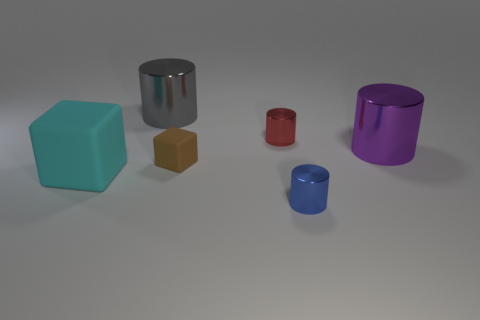Does the gray thing have the same size as the red metal object?
Your answer should be very brief. No. There is a thing that is left of the large metal thing to the left of the small brown rubber thing behind the large cyan rubber object; what is its material?
Your answer should be very brief. Rubber. Is the tiny cylinder that is in front of the big purple cylinder made of the same material as the tiny brown object?
Provide a short and direct response. No. What shape is the big object that is on the left side of the tiny red cylinder and in front of the gray thing?
Make the answer very short. Cube. What number of tiny things are cyan rubber things or shiny cylinders?
Keep it short and to the point. 2. What is the material of the small brown thing?
Give a very brief answer. Rubber. How many other objects are the same shape as the big rubber thing?
Your response must be concise. 1. How big is the cyan matte cube?
Offer a very short reply. Large. What is the size of the object that is both in front of the tiny rubber block and on the right side of the large cyan rubber cube?
Your answer should be compact. Small. The big thing left of the large gray cylinder has what shape?
Provide a succinct answer. Cube. 